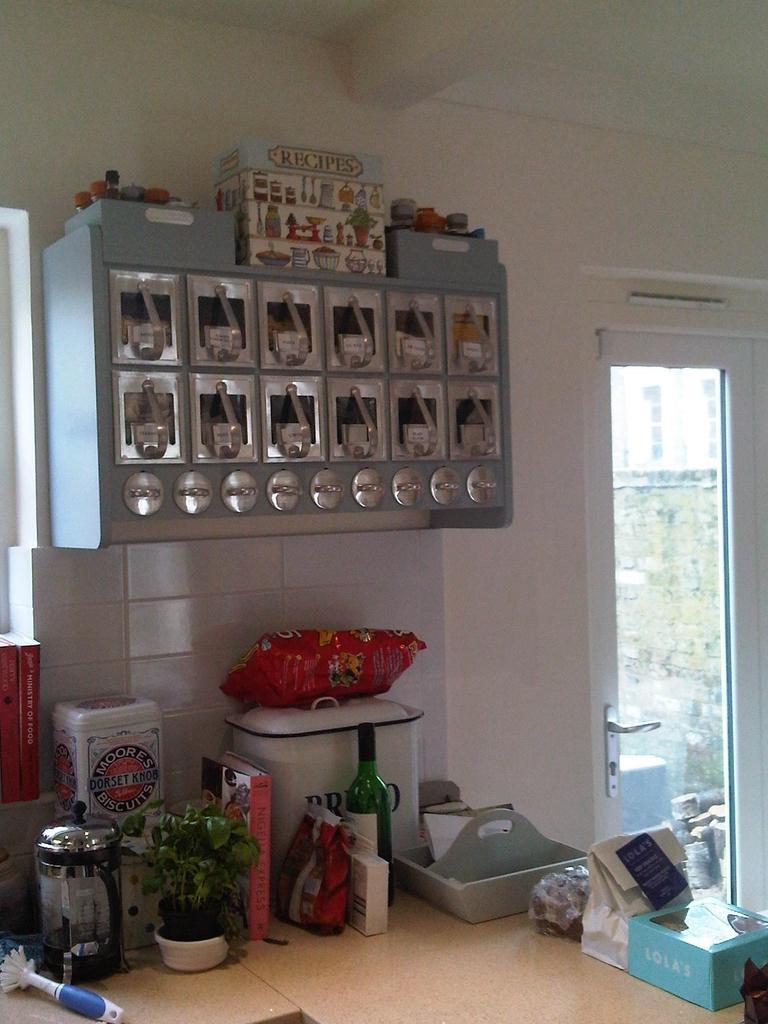Please provide a concise description of this image. Bottom of the image there is a table, on the table there is a bottle, plant and there are some boxes and there are some bags. Top of the image there is roof. Top left side of the image there is a wall, on the wall there is a cupboard. Bottom right side of the image there is a door. Through the door we can see a wall. 